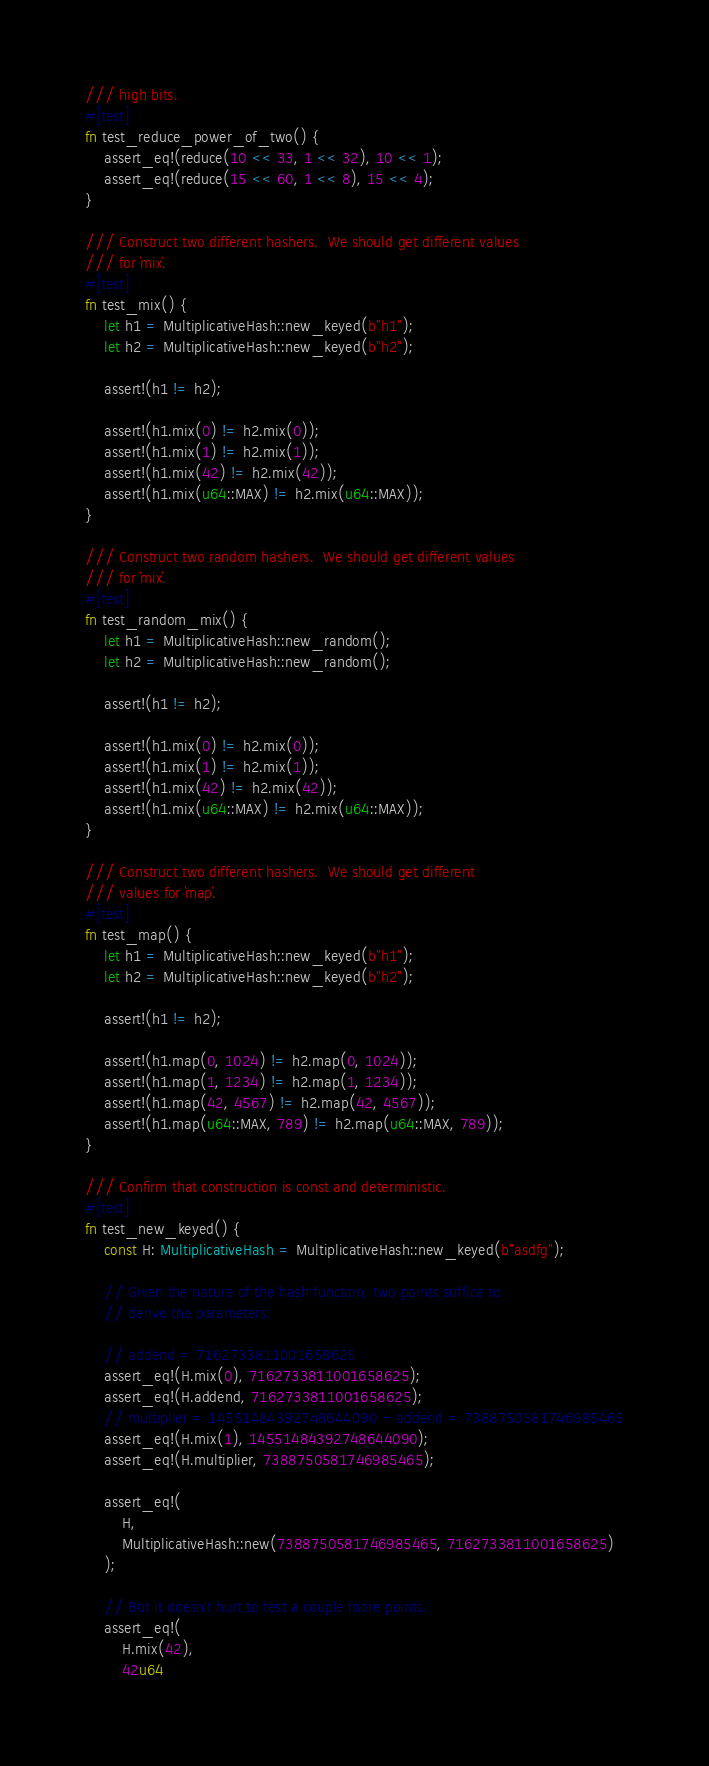Convert code to text. <code><loc_0><loc_0><loc_500><loc_500><_Rust_>/// high bits.
#[test]
fn test_reduce_power_of_two() {
    assert_eq!(reduce(10 << 33, 1 << 32), 10 << 1);
    assert_eq!(reduce(15 << 60, 1 << 8), 15 << 4);
}

/// Construct two different hashers.  We should get different values
/// for `mix`.
#[test]
fn test_mix() {
    let h1 = MultiplicativeHash::new_keyed(b"h1");
    let h2 = MultiplicativeHash::new_keyed(b"h2");

    assert!(h1 != h2);

    assert!(h1.mix(0) != h2.mix(0));
    assert!(h1.mix(1) != h2.mix(1));
    assert!(h1.mix(42) != h2.mix(42));
    assert!(h1.mix(u64::MAX) != h2.mix(u64::MAX));
}

/// Construct two random hashers.  We should get different values
/// for `mix`.
#[test]
fn test_random_mix() {
    let h1 = MultiplicativeHash::new_random();
    let h2 = MultiplicativeHash::new_random();

    assert!(h1 != h2);

    assert!(h1.mix(0) != h2.mix(0));
    assert!(h1.mix(1) != h2.mix(1));
    assert!(h1.mix(42) != h2.mix(42));
    assert!(h1.mix(u64::MAX) != h2.mix(u64::MAX));
}

/// Construct two different hashers.  We should get different
/// values for `map`.
#[test]
fn test_map() {
    let h1 = MultiplicativeHash::new_keyed(b"h1");
    let h2 = MultiplicativeHash::new_keyed(b"h2");

    assert!(h1 != h2);

    assert!(h1.map(0, 1024) != h2.map(0, 1024));
    assert!(h1.map(1, 1234) != h2.map(1, 1234));
    assert!(h1.map(42, 4567) != h2.map(42, 4567));
    assert!(h1.map(u64::MAX, 789) != h2.map(u64::MAX, 789));
}

/// Confirm that construction is const and deterministic.
#[test]
fn test_new_keyed() {
    const H: MultiplicativeHash = MultiplicativeHash::new_keyed(b"asdfg");

    // Given the nature of the hash function, two points suffice to
    // derive the parameters.

    // addend = 7162733811001658625
    assert_eq!(H.mix(0), 7162733811001658625);
    assert_eq!(H.addend, 7162733811001658625);
    // multiplier = 14551484392748644090 - addend = 7388750581746985465
    assert_eq!(H.mix(1), 14551484392748644090);
    assert_eq!(H.multiplier, 7388750581746985465);

    assert_eq!(
        H,
        MultiplicativeHash::new(7388750581746985465, 7162733811001658625)
    );

    // But it doesn't hurt to test a couple more points.
    assert_eq!(
        H.mix(42),
        42u64</code> 